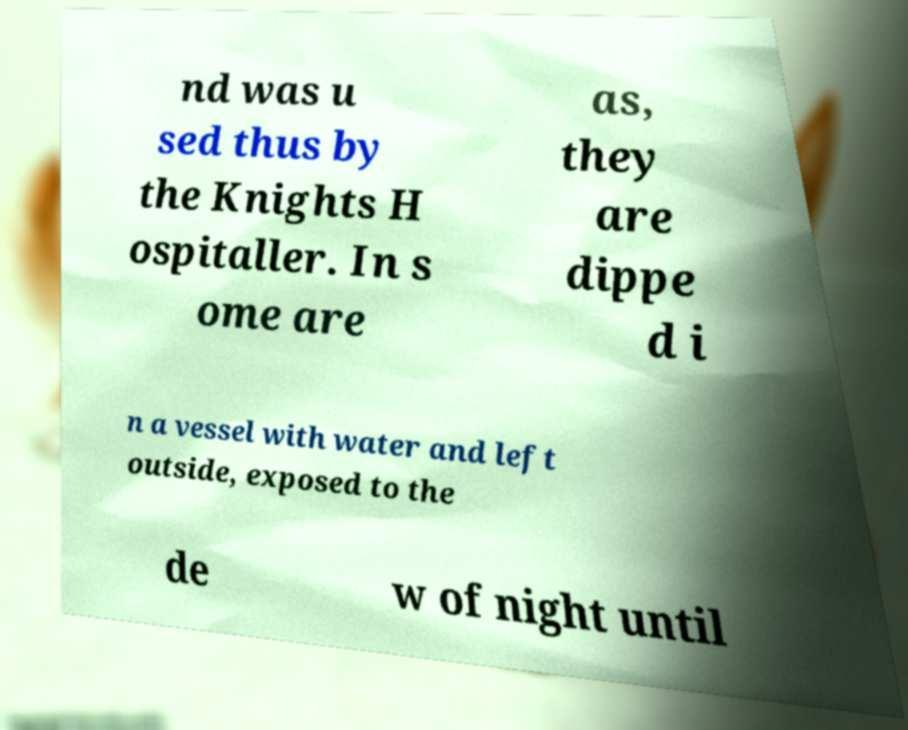Please read and relay the text visible in this image. What does it say? nd was u sed thus by the Knights H ospitaller. In s ome are as, they are dippe d i n a vessel with water and left outside, exposed to the de w of night until 